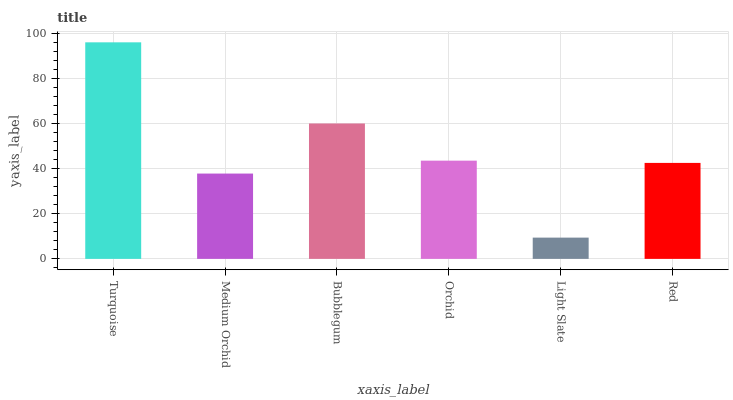Is Light Slate the minimum?
Answer yes or no. Yes. Is Turquoise the maximum?
Answer yes or no. Yes. Is Medium Orchid the minimum?
Answer yes or no. No. Is Medium Orchid the maximum?
Answer yes or no. No. Is Turquoise greater than Medium Orchid?
Answer yes or no. Yes. Is Medium Orchid less than Turquoise?
Answer yes or no. Yes. Is Medium Orchid greater than Turquoise?
Answer yes or no. No. Is Turquoise less than Medium Orchid?
Answer yes or no. No. Is Orchid the high median?
Answer yes or no. Yes. Is Red the low median?
Answer yes or no. Yes. Is Light Slate the high median?
Answer yes or no. No. Is Turquoise the low median?
Answer yes or no. No. 